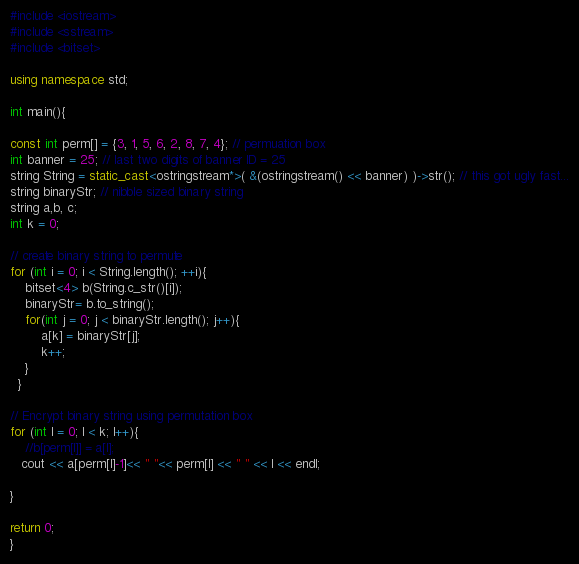<code> <loc_0><loc_0><loc_500><loc_500><_C++_>#include <iostream>
#include <sstream>
#include <bitset>

using namespace std;

int main(){

const int perm[] = {3, 1, 5, 6, 2, 8, 7, 4}; // permuation box
int banner = 25; // last two digits of banner ID = 25
string String = static_cast<ostringstream*>( &(ostringstream() << banner) )->str(); // this got ugly fast...
string binaryStr; // nibble sized binary string
string a,b, c;
int k = 0;

// create binary string to permute
for (int i = 0; i < String.length(); ++i){
    bitset<4> b(String.c_str()[i]);
    binaryStr= b.to_string();
    for(int j = 0; j < binaryStr.length(); j++){
        a[k] = binaryStr[j];
        k++;
    }
  }

// Encrypt binary string using permutation box
for (int l = 0; l < k; l++){
    //b[perm[l]] = a[l];
   cout << a[perm[l]-1]<< " "<< perm[l] << " " << l << endl;

}

return 0;
}
</code> 